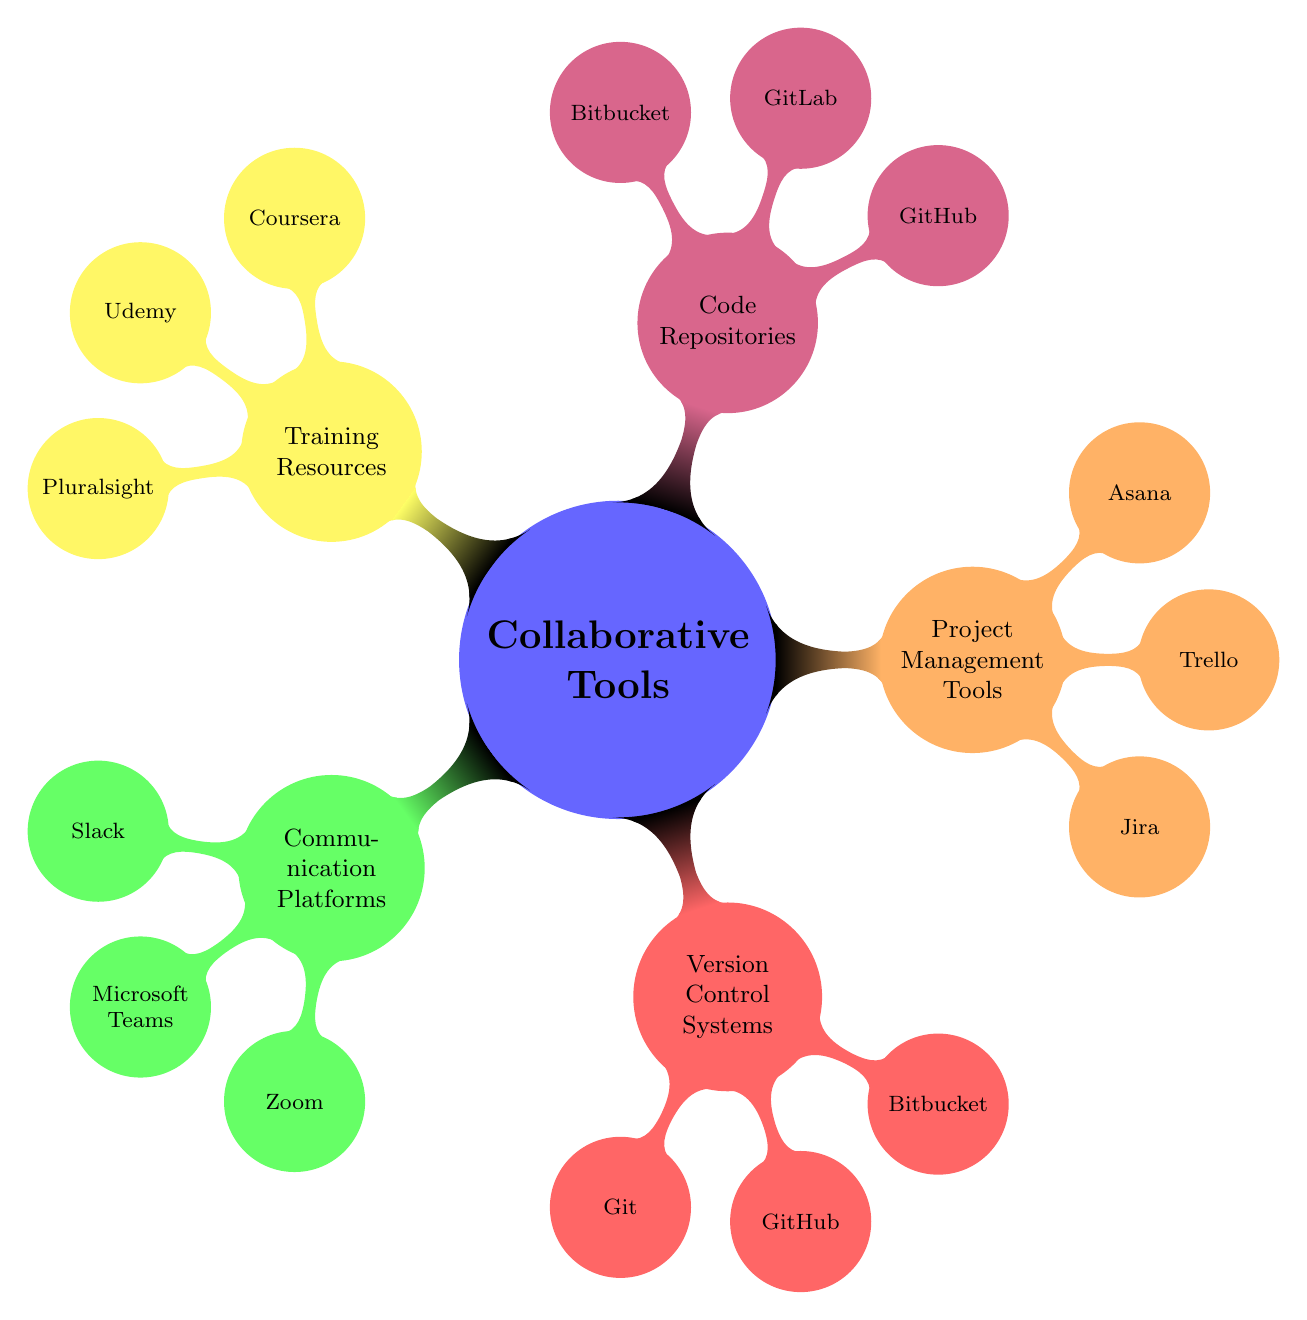What are the three main categories under Collaborative Tools? The diagram shows five main categories under Collaborative Tools, which are Communication Platforms, Version Control Systems, Project Management Tools, Code Repositories, and Training Resources.
Answer: Communication Platforms, Version Control Systems, Project Management Tools Which communication platform is known for video conferencing? Among the listed communication platforms, Zoom is specifically mentioned for video conferencing and webinars.
Answer: Zoom How many tools are listed under Project Management Tools? The Project Management Tools section has three tools listed: Jira, Trello, and Asana.
Answer: Three What is a common feature of both GitHub and Bitbucket? Both GitHub and Bitbucket are listed under Code Repositories, and they serve as web-based hosting services for source code and development projects.
Answer: Hosting service Which training resource focuses on technology skill development? Pluralsight is identified as the training resource that is specifically focused on technology skill development.
Answer: Pluralsight What is the unique function of Slack compared to Microsoft Teams? Slack is described primarily for real-time messaging and file sharing, while Microsoft Teams also includes chat, meetings, and app integration, making Slack more focused on messaging.
Answer: Real-time messaging How many tools are mentioned in the Version Control Systems category? The Version Control Systems section contains three tools: Git, GitHub, and Bitbucket, therefore the count is three.
Answer: Three Which tool is shared between both Code Repositories and Version Control Systems? GitHub is the only tool that appears in both the Code Repositories and Version Control Systems categories, indicating its dual role.
Answer: GitHub How are Jira and Asana different in terms of their functionalities? Jira focuses on issue and project tracking, while Asana is geared towards task and workflow management; thus they serve different project needs.
Answer: Different functionalities 